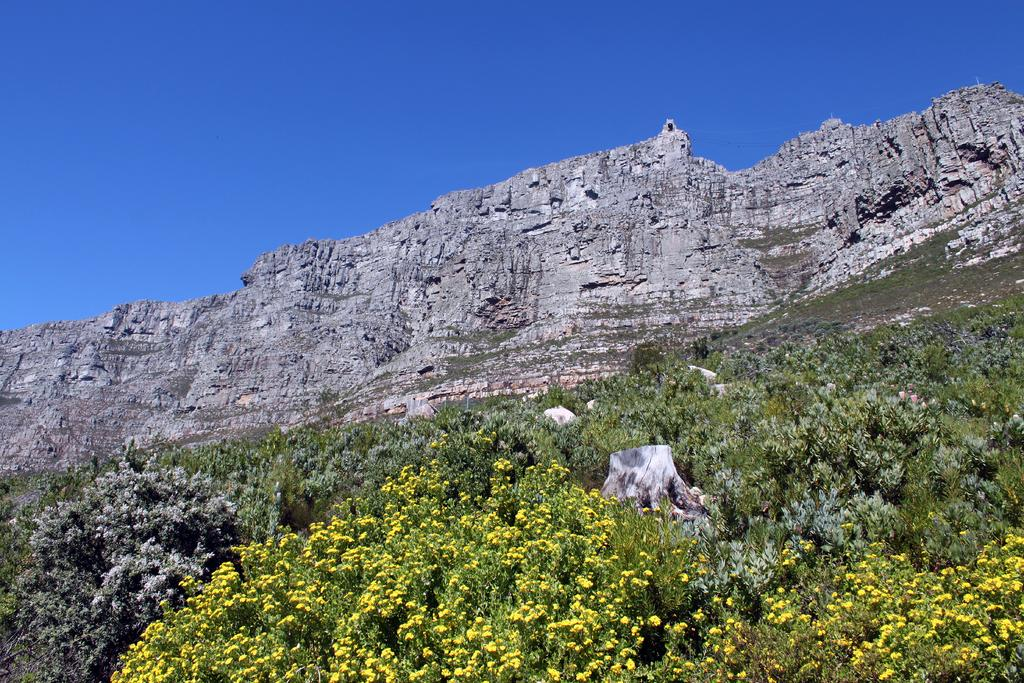What is the main feature in the center of the image? There are mountains in the center of the image. What type of vegetation can be seen in the image? There are plants and flowers in the image. What is visible at the top of the image? The sky is visible at the top of the image. Where is the amusement park located in the image? There is no amusement park present in the image. What type of lunchroom can be seen in the image? There is no lunchroom present in the image. 